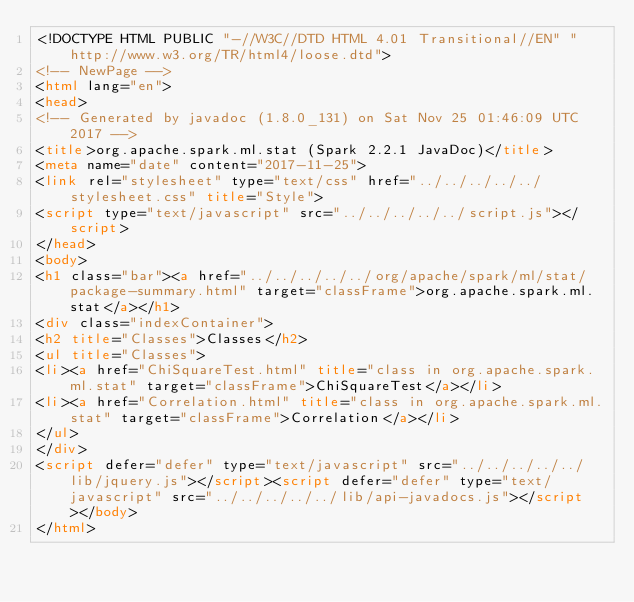<code> <loc_0><loc_0><loc_500><loc_500><_HTML_><!DOCTYPE HTML PUBLIC "-//W3C//DTD HTML 4.01 Transitional//EN" "http://www.w3.org/TR/html4/loose.dtd">
<!-- NewPage -->
<html lang="en">
<head>
<!-- Generated by javadoc (1.8.0_131) on Sat Nov 25 01:46:09 UTC 2017 -->
<title>org.apache.spark.ml.stat (Spark 2.2.1 JavaDoc)</title>
<meta name="date" content="2017-11-25">
<link rel="stylesheet" type="text/css" href="../../../../../stylesheet.css" title="Style">
<script type="text/javascript" src="../../../../../script.js"></script>
</head>
<body>
<h1 class="bar"><a href="../../../../../org/apache/spark/ml/stat/package-summary.html" target="classFrame">org.apache.spark.ml.stat</a></h1>
<div class="indexContainer">
<h2 title="Classes">Classes</h2>
<ul title="Classes">
<li><a href="ChiSquareTest.html" title="class in org.apache.spark.ml.stat" target="classFrame">ChiSquareTest</a></li>
<li><a href="Correlation.html" title="class in org.apache.spark.ml.stat" target="classFrame">Correlation</a></li>
</ul>
</div>
<script defer="defer" type="text/javascript" src="../../../../../lib/jquery.js"></script><script defer="defer" type="text/javascript" src="../../../../../lib/api-javadocs.js"></script></body>
</html>
</code> 